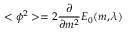Convert formula to latex. <formula><loc_0><loc_0><loc_500><loc_500>< \phi ^ { 2 } > = 2 \frac { \partial } { \partial m ^ { 2 } } E _ { 0 } ( m , \lambda )</formula> 